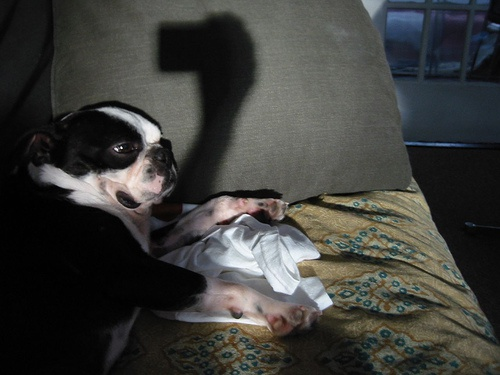Describe the objects in this image and their specific colors. I can see dog in black, gray, darkgray, and lightgray tones, bed in black and gray tones, and chair in black, navy, darkblue, and gray tones in this image. 